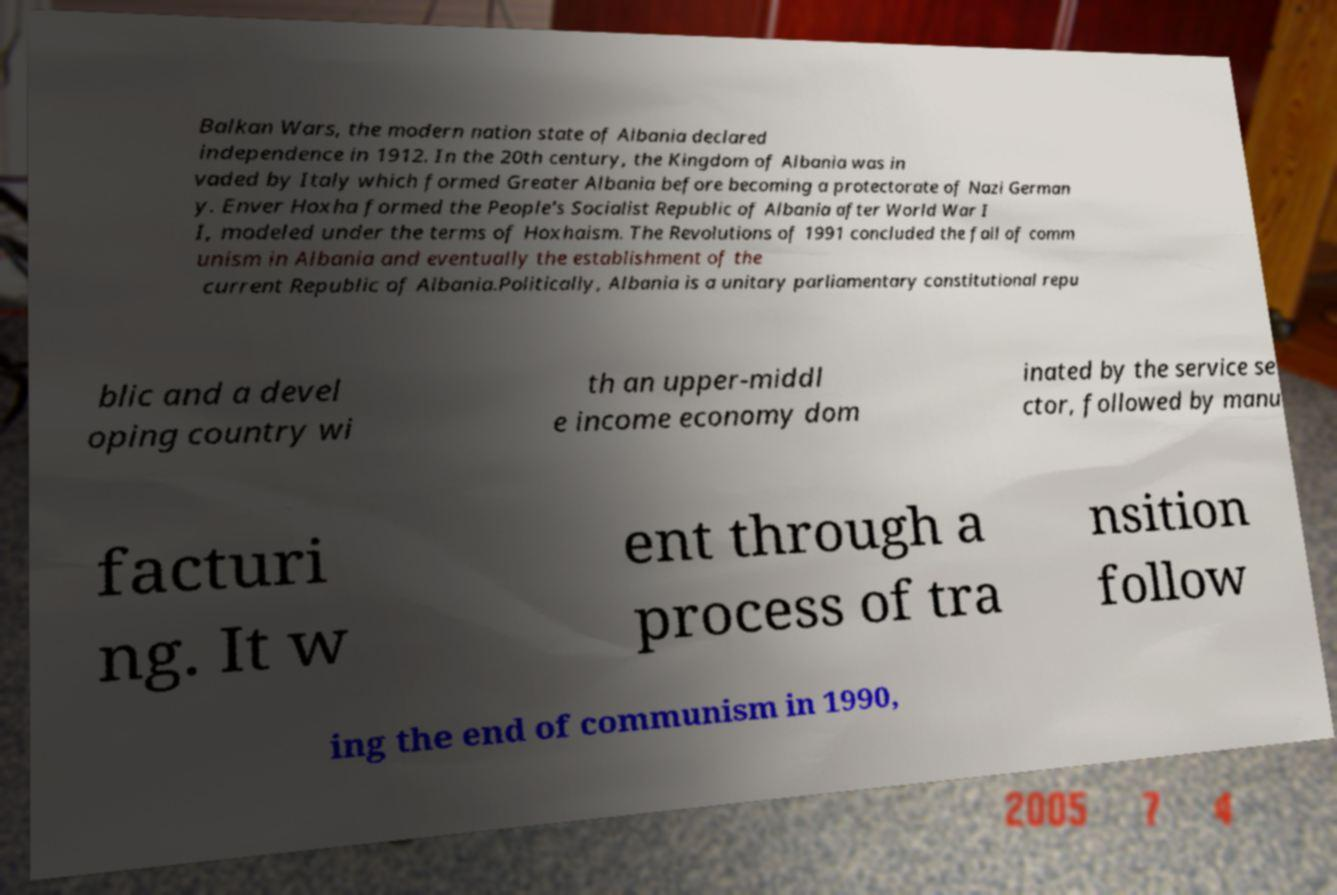Can you read and provide the text displayed in the image?This photo seems to have some interesting text. Can you extract and type it out for me? Balkan Wars, the modern nation state of Albania declared independence in 1912. In the 20th century, the Kingdom of Albania was in vaded by Italy which formed Greater Albania before becoming a protectorate of Nazi German y. Enver Hoxha formed the People's Socialist Republic of Albania after World War I I, modeled under the terms of Hoxhaism. The Revolutions of 1991 concluded the fall of comm unism in Albania and eventually the establishment of the current Republic of Albania.Politically, Albania is a unitary parliamentary constitutional repu blic and a devel oping country wi th an upper-middl e income economy dom inated by the service se ctor, followed by manu facturi ng. It w ent through a process of tra nsition follow ing the end of communism in 1990, 